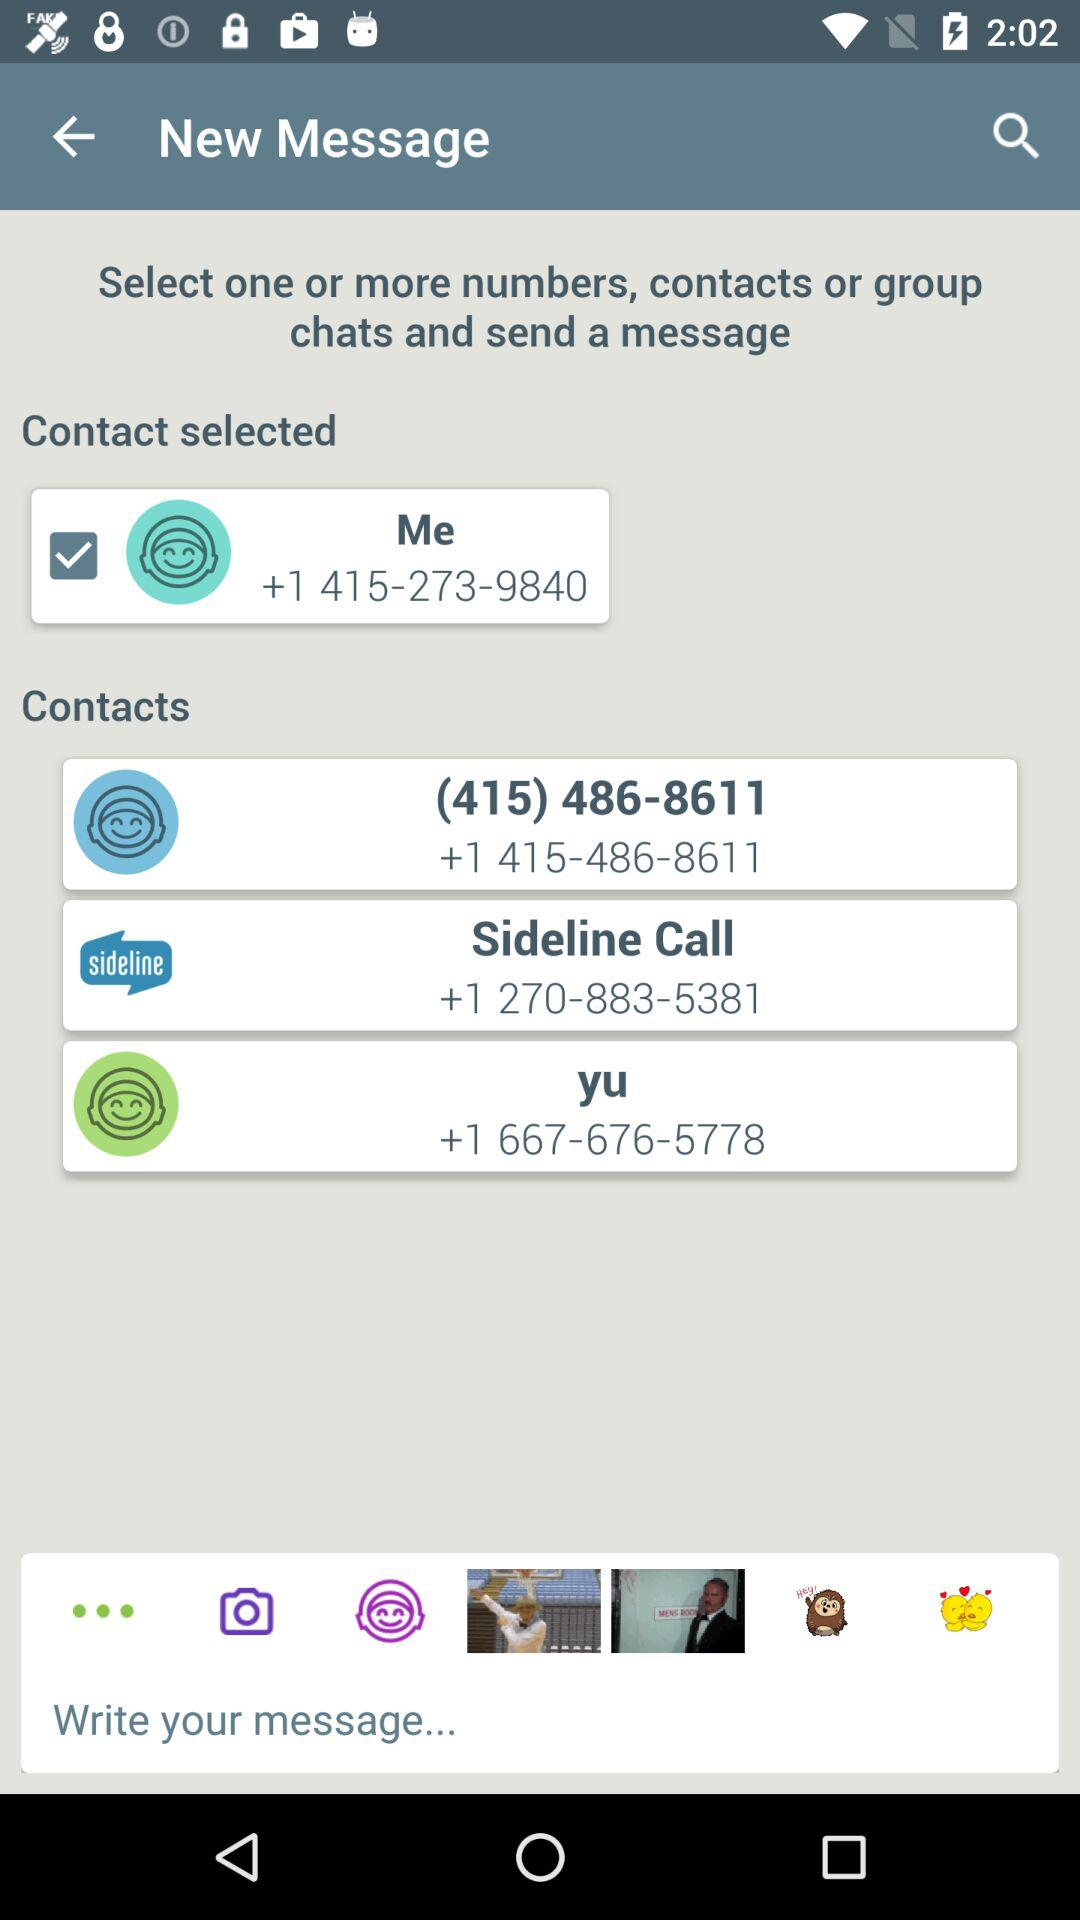What is the number of the sideline call? The number of the sideline call is +1 270-883-5381. 